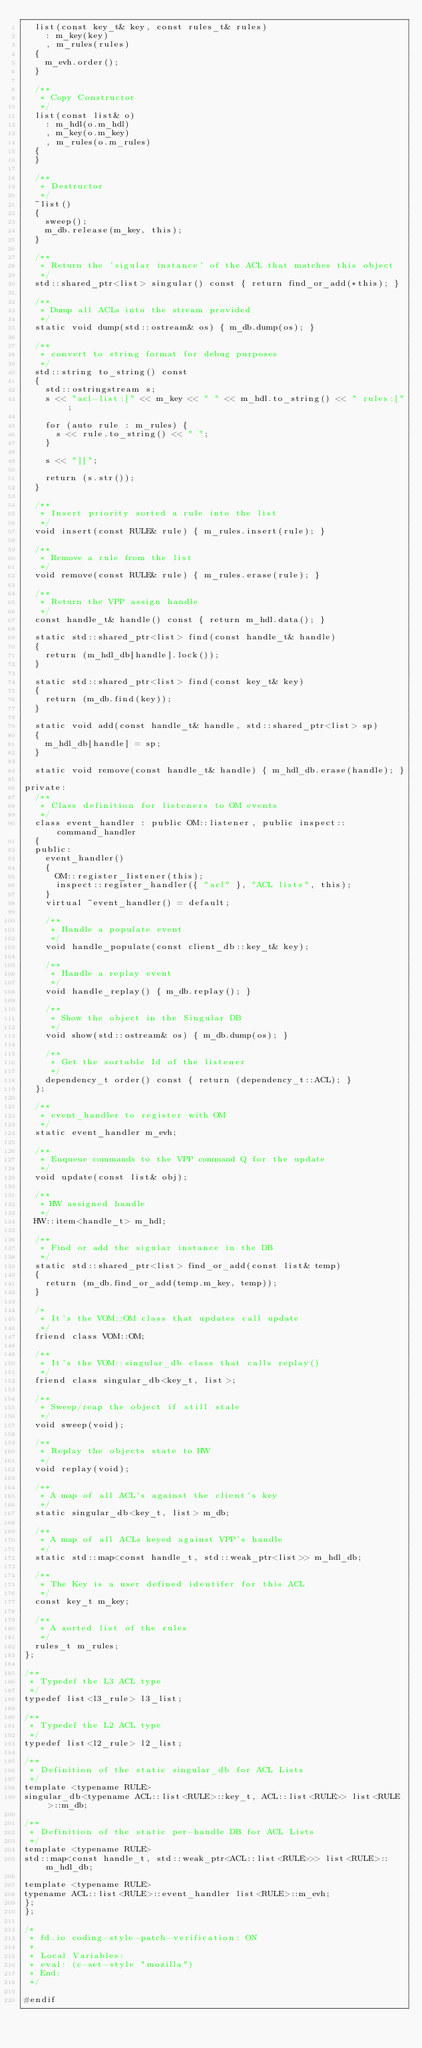<code> <loc_0><loc_0><loc_500><loc_500><_C++_>  list(const key_t& key, const rules_t& rules)
    : m_key(key)
    , m_rules(rules)
  {
    m_evh.order();
  }

  /**
   * Copy Constructor
   */
  list(const list& o)
    : m_hdl(o.m_hdl)
    , m_key(o.m_key)
    , m_rules(o.m_rules)
  {
  }

  /**
   * Destructor
   */
  ~list()
  {
    sweep();
    m_db.release(m_key, this);
  }

  /**
   * Return the 'sigular instance' of the ACL that matches this object
   */
  std::shared_ptr<list> singular() const { return find_or_add(*this); }

  /**
   * Dump all ACLs into the stream provided
   */
  static void dump(std::ostream& os) { m_db.dump(os); }

  /**
   * convert to string format for debug purposes
   */
  std::string to_string() const
  {
    std::ostringstream s;
    s << "acl-list:[" << m_key << " " << m_hdl.to_string() << " rules:[";

    for (auto rule : m_rules) {
      s << rule.to_string() << " ";
    }

    s << "]]";

    return (s.str());
  }

  /**
   * Insert priority sorted a rule into the list
   */
  void insert(const RULE& rule) { m_rules.insert(rule); }

  /**
   * Remove a rule from the list
   */
  void remove(const RULE& rule) { m_rules.erase(rule); }

  /**
   * Return the VPP assign handle
   */
  const handle_t& handle() const { return m_hdl.data(); }

  static std::shared_ptr<list> find(const handle_t& handle)
  {
    return (m_hdl_db[handle].lock());
  }

  static std::shared_ptr<list> find(const key_t& key)
  {
    return (m_db.find(key));
  }

  static void add(const handle_t& handle, std::shared_ptr<list> sp)
  {
    m_hdl_db[handle] = sp;
  }

  static void remove(const handle_t& handle) { m_hdl_db.erase(handle); }

private:
  /**
   * Class definition for listeners to OM events
   */
  class event_handler : public OM::listener, public inspect::command_handler
  {
  public:
    event_handler()
    {
      OM::register_listener(this);
      inspect::register_handler({ "acl" }, "ACL lists", this);
    }
    virtual ~event_handler() = default;

    /**
     * Handle a populate event
     */
    void handle_populate(const client_db::key_t& key);

    /**
     * Handle a replay event
     */
    void handle_replay() { m_db.replay(); }

    /**
     * Show the object in the Singular DB
     */
    void show(std::ostream& os) { m_db.dump(os); }

    /**
     * Get the sortable Id of the listener
     */
    dependency_t order() const { return (dependency_t::ACL); }
  };

  /**
   * event_handler to register with OM
   */
  static event_handler m_evh;

  /**
   * Enqueue commands to the VPP command Q for the update
   */
  void update(const list& obj);

  /**
   * HW assigned handle
   */
  HW::item<handle_t> m_hdl;

  /**
   * Find or add the sigular instance in the DB
   */
  static std::shared_ptr<list> find_or_add(const list& temp)
  {
    return (m_db.find_or_add(temp.m_key, temp));
  }

  /*
   * It's the VOM::OM class that updates call update
   */
  friend class VOM::OM;

  /**
   * It's the VOM::singular_db class that calls replay()
   */
  friend class singular_db<key_t, list>;

  /**
   * Sweep/reap the object if still stale
   */
  void sweep(void);

  /**
   * Replay the objects state to HW
   */
  void replay(void);

  /**
   * A map of all ACL's against the client's key
   */
  static singular_db<key_t, list> m_db;

  /**
   * A map of all ACLs keyed against VPP's handle
   */
  static std::map<const handle_t, std::weak_ptr<list>> m_hdl_db;

  /**
   * The Key is a user defined identifer for this ACL
   */
  const key_t m_key;

  /**
   * A sorted list of the rules
   */
  rules_t m_rules;
};

/**
 * Typedef the L3 ACL type
 */
typedef list<l3_rule> l3_list;

/**
 * Typedef the L2 ACL type
 */
typedef list<l2_rule> l2_list;

/**
 * Definition of the static singular_db for ACL Lists
 */
template <typename RULE>
singular_db<typename ACL::list<RULE>::key_t, ACL::list<RULE>> list<RULE>::m_db;

/**
 * Definition of the static per-handle DB for ACL Lists
 */
template <typename RULE>
std::map<const handle_t, std::weak_ptr<ACL::list<RULE>>> list<RULE>::m_hdl_db;

template <typename RULE>
typename ACL::list<RULE>::event_handler list<RULE>::m_evh;
};
};

/*
 * fd.io coding-style-patch-verification: ON
 *
 * Local Variables:
 * eval: (c-set-style "mozilla")
 * End:
 */

#endif
</code> 